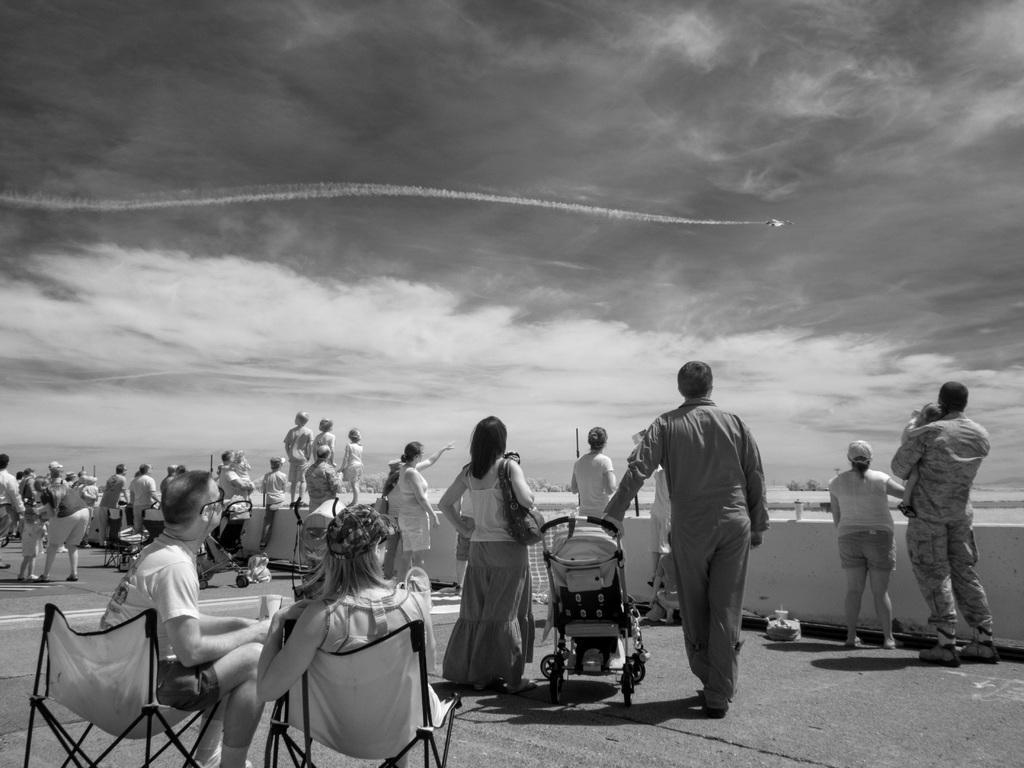Describe this image in one or two sentences. In this image, In the left side there are some people sitting on the chairs, In the middle there are some standing and they are holding a small car, In the right side there are some people standing, In the background there is a sky which is in black color and there is a object flying. 